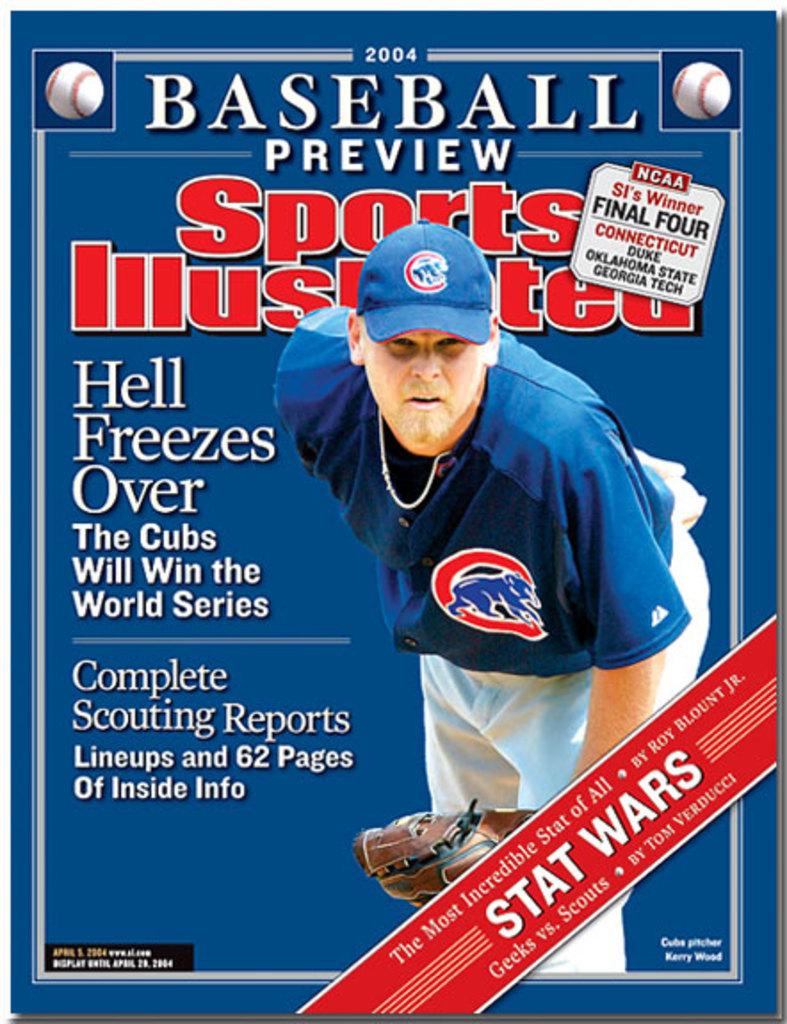What team of lovable losers is featured in the magazine?
Give a very brief answer. Cubs. What year is the publication?
Your response must be concise. 2004. 